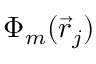Convert formula to latex. <formula><loc_0><loc_0><loc_500><loc_500>\Phi _ { m } ( \vec { r } _ { j } )</formula> 